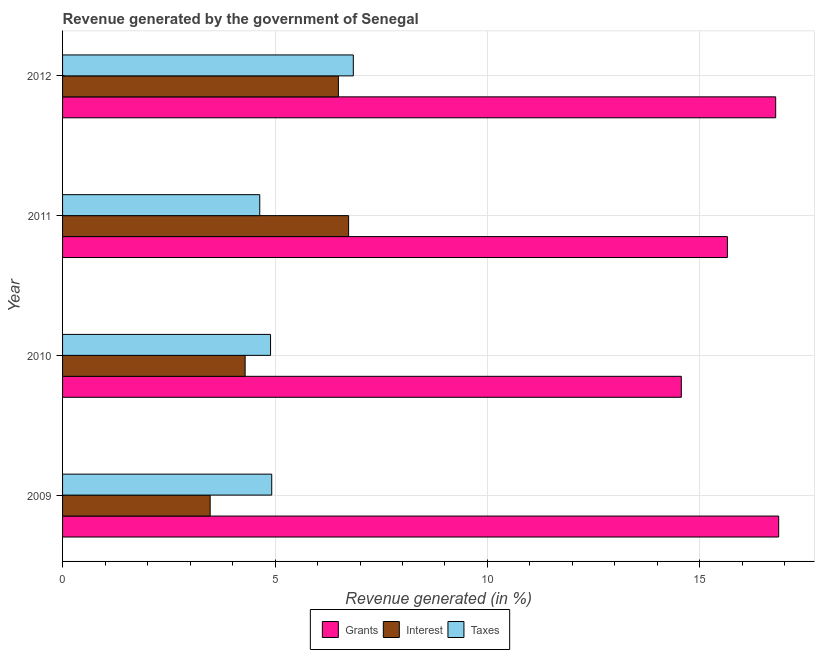How many groups of bars are there?
Provide a succinct answer. 4. Are the number of bars on each tick of the Y-axis equal?
Give a very brief answer. Yes. What is the label of the 2nd group of bars from the top?
Your answer should be compact. 2011. In how many cases, is the number of bars for a given year not equal to the number of legend labels?
Ensure brevity in your answer.  0. What is the percentage of revenue generated by grants in 2011?
Make the answer very short. 15.65. Across all years, what is the maximum percentage of revenue generated by taxes?
Your response must be concise. 6.84. Across all years, what is the minimum percentage of revenue generated by interest?
Your answer should be compact. 3.47. What is the total percentage of revenue generated by grants in the graph?
Your answer should be compact. 63.84. What is the difference between the percentage of revenue generated by interest in 2011 and that in 2012?
Keep it short and to the point. 0.24. What is the difference between the percentage of revenue generated by grants in 2010 and the percentage of revenue generated by taxes in 2011?
Offer a very short reply. 9.92. What is the average percentage of revenue generated by taxes per year?
Keep it short and to the point. 5.33. In the year 2009, what is the difference between the percentage of revenue generated by taxes and percentage of revenue generated by grants?
Your answer should be very brief. -11.93. What is the ratio of the percentage of revenue generated by taxes in 2011 to that in 2012?
Provide a short and direct response. 0.68. Is the percentage of revenue generated by interest in 2009 less than that in 2010?
Make the answer very short. Yes. What is the difference between the highest and the second highest percentage of revenue generated by grants?
Your answer should be compact. 0.07. What is the difference between the highest and the lowest percentage of revenue generated by grants?
Keep it short and to the point. 2.29. Is the sum of the percentage of revenue generated by interest in 2010 and 2011 greater than the maximum percentage of revenue generated by taxes across all years?
Offer a terse response. Yes. What does the 3rd bar from the top in 2010 represents?
Provide a succinct answer. Grants. What does the 2nd bar from the bottom in 2012 represents?
Ensure brevity in your answer.  Interest. Is it the case that in every year, the sum of the percentage of revenue generated by grants and percentage of revenue generated by interest is greater than the percentage of revenue generated by taxes?
Ensure brevity in your answer.  Yes. Does the graph contain any zero values?
Offer a very short reply. No. Where does the legend appear in the graph?
Provide a succinct answer. Bottom center. How many legend labels are there?
Offer a terse response. 3. How are the legend labels stacked?
Keep it short and to the point. Horizontal. What is the title of the graph?
Keep it short and to the point. Revenue generated by the government of Senegal. Does "Profit Tax" appear as one of the legend labels in the graph?
Your answer should be compact. No. What is the label or title of the X-axis?
Make the answer very short. Revenue generated (in %). What is the Revenue generated (in %) in Grants in 2009?
Give a very brief answer. 16.85. What is the Revenue generated (in %) in Interest in 2009?
Give a very brief answer. 3.47. What is the Revenue generated (in %) in Taxes in 2009?
Your answer should be compact. 4.92. What is the Revenue generated (in %) of Grants in 2010?
Make the answer very short. 14.56. What is the Revenue generated (in %) in Interest in 2010?
Your answer should be very brief. 4.3. What is the Revenue generated (in %) of Taxes in 2010?
Make the answer very short. 4.89. What is the Revenue generated (in %) in Grants in 2011?
Your answer should be very brief. 15.65. What is the Revenue generated (in %) in Interest in 2011?
Make the answer very short. 6.73. What is the Revenue generated (in %) of Taxes in 2011?
Give a very brief answer. 4.64. What is the Revenue generated (in %) in Grants in 2012?
Make the answer very short. 16.78. What is the Revenue generated (in %) in Interest in 2012?
Make the answer very short. 6.49. What is the Revenue generated (in %) in Taxes in 2012?
Give a very brief answer. 6.84. Across all years, what is the maximum Revenue generated (in %) of Grants?
Offer a very short reply. 16.85. Across all years, what is the maximum Revenue generated (in %) of Interest?
Provide a short and direct response. 6.73. Across all years, what is the maximum Revenue generated (in %) in Taxes?
Provide a short and direct response. 6.84. Across all years, what is the minimum Revenue generated (in %) in Grants?
Ensure brevity in your answer.  14.56. Across all years, what is the minimum Revenue generated (in %) of Interest?
Your answer should be very brief. 3.47. Across all years, what is the minimum Revenue generated (in %) of Taxes?
Ensure brevity in your answer.  4.64. What is the total Revenue generated (in %) in Grants in the graph?
Offer a terse response. 63.84. What is the total Revenue generated (in %) of Interest in the graph?
Offer a very short reply. 20.99. What is the total Revenue generated (in %) of Taxes in the graph?
Your answer should be very brief. 21.3. What is the difference between the Revenue generated (in %) of Grants in 2009 and that in 2010?
Your response must be concise. 2.29. What is the difference between the Revenue generated (in %) of Interest in 2009 and that in 2010?
Give a very brief answer. -0.82. What is the difference between the Revenue generated (in %) in Taxes in 2009 and that in 2010?
Provide a succinct answer. 0.03. What is the difference between the Revenue generated (in %) in Grants in 2009 and that in 2011?
Provide a succinct answer. 1.21. What is the difference between the Revenue generated (in %) of Interest in 2009 and that in 2011?
Your answer should be compact. -3.26. What is the difference between the Revenue generated (in %) of Taxes in 2009 and that in 2011?
Offer a very short reply. 0.28. What is the difference between the Revenue generated (in %) of Grants in 2009 and that in 2012?
Your response must be concise. 0.07. What is the difference between the Revenue generated (in %) of Interest in 2009 and that in 2012?
Your response must be concise. -3.02. What is the difference between the Revenue generated (in %) in Taxes in 2009 and that in 2012?
Keep it short and to the point. -1.92. What is the difference between the Revenue generated (in %) in Grants in 2010 and that in 2011?
Provide a short and direct response. -1.08. What is the difference between the Revenue generated (in %) in Interest in 2010 and that in 2011?
Make the answer very short. -2.44. What is the difference between the Revenue generated (in %) of Taxes in 2010 and that in 2011?
Offer a very short reply. 0.25. What is the difference between the Revenue generated (in %) in Grants in 2010 and that in 2012?
Offer a terse response. -2.22. What is the difference between the Revenue generated (in %) of Interest in 2010 and that in 2012?
Your response must be concise. -2.2. What is the difference between the Revenue generated (in %) of Taxes in 2010 and that in 2012?
Your response must be concise. -1.95. What is the difference between the Revenue generated (in %) of Grants in 2011 and that in 2012?
Ensure brevity in your answer.  -1.14. What is the difference between the Revenue generated (in %) of Interest in 2011 and that in 2012?
Give a very brief answer. 0.24. What is the difference between the Revenue generated (in %) of Taxes in 2011 and that in 2012?
Ensure brevity in your answer.  -2.2. What is the difference between the Revenue generated (in %) of Grants in 2009 and the Revenue generated (in %) of Interest in 2010?
Ensure brevity in your answer.  12.56. What is the difference between the Revenue generated (in %) of Grants in 2009 and the Revenue generated (in %) of Taxes in 2010?
Provide a short and direct response. 11.96. What is the difference between the Revenue generated (in %) of Interest in 2009 and the Revenue generated (in %) of Taxes in 2010?
Your answer should be compact. -1.42. What is the difference between the Revenue generated (in %) of Grants in 2009 and the Revenue generated (in %) of Interest in 2011?
Provide a succinct answer. 10.12. What is the difference between the Revenue generated (in %) in Grants in 2009 and the Revenue generated (in %) in Taxes in 2011?
Provide a succinct answer. 12.21. What is the difference between the Revenue generated (in %) of Interest in 2009 and the Revenue generated (in %) of Taxes in 2011?
Ensure brevity in your answer.  -1.17. What is the difference between the Revenue generated (in %) of Grants in 2009 and the Revenue generated (in %) of Interest in 2012?
Provide a succinct answer. 10.36. What is the difference between the Revenue generated (in %) in Grants in 2009 and the Revenue generated (in %) in Taxes in 2012?
Give a very brief answer. 10.01. What is the difference between the Revenue generated (in %) in Interest in 2009 and the Revenue generated (in %) in Taxes in 2012?
Provide a short and direct response. -3.37. What is the difference between the Revenue generated (in %) of Grants in 2010 and the Revenue generated (in %) of Interest in 2011?
Your response must be concise. 7.83. What is the difference between the Revenue generated (in %) in Grants in 2010 and the Revenue generated (in %) in Taxes in 2011?
Make the answer very short. 9.92. What is the difference between the Revenue generated (in %) of Interest in 2010 and the Revenue generated (in %) of Taxes in 2011?
Offer a terse response. -0.34. What is the difference between the Revenue generated (in %) of Grants in 2010 and the Revenue generated (in %) of Interest in 2012?
Your answer should be very brief. 8.07. What is the difference between the Revenue generated (in %) in Grants in 2010 and the Revenue generated (in %) in Taxes in 2012?
Your answer should be very brief. 7.72. What is the difference between the Revenue generated (in %) of Interest in 2010 and the Revenue generated (in %) of Taxes in 2012?
Give a very brief answer. -2.55. What is the difference between the Revenue generated (in %) in Grants in 2011 and the Revenue generated (in %) in Interest in 2012?
Offer a terse response. 9.15. What is the difference between the Revenue generated (in %) in Grants in 2011 and the Revenue generated (in %) in Taxes in 2012?
Provide a succinct answer. 8.8. What is the difference between the Revenue generated (in %) of Interest in 2011 and the Revenue generated (in %) of Taxes in 2012?
Offer a very short reply. -0.11. What is the average Revenue generated (in %) of Grants per year?
Make the answer very short. 15.96. What is the average Revenue generated (in %) of Interest per year?
Make the answer very short. 5.25. What is the average Revenue generated (in %) in Taxes per year?
Your response must be concise. 5.33. In the year 2009, what is the difference between the Revenue generated (in %) of Grants and Revenue generated (in %) of Interest?
Provide a succinct answer. 13.38. In the year 2009, what is the difference between the Revenue generated (in %) in Grants and Revenue generated (in %) in Taxes?
Make the answer very short. 11.93. In the year 2009, what is the difference between the Revenue generated (in %) of Interest and Revenue generated (in %) of Taxes?
Your response must be concise. -1.45. In the year 2010, what is the difference between the Revenue generated (in %) in Grants and Revenue generated (in %) in Interest?
Provide a succinct answer. 10.27. In the year 2010, what is the difference between the Revenue generated (in %) of Grants and Revenue generated (in %) of Taxes?
Make the answer very short. 9.67. In the year 2010, what is the difference between the Revenue generated (in %) in Interest and Revenue generated (in %) in Taxes?
Keep it short and to the point. -0.6. In the year 2011, what is the difference between the Revenue generated (in %) in Grants and Revenue generated (in %) in Interest?
Your answer should be compact. 8.91. In the year 2011, what is the difference between the Revenue generated (in %) in Grants and Revenue generated (in %) in Taxes?
Your answer should be very brief. 11.01. In the year 2011, what is the difference between the Revenue generated (in %) of Interest and Revenue generated (in %) of Taxes?
Your answer should be very brief. 2.09. In the year 2012, what is the difference between the Revenue generated (in %) of Grants and Revenue generated (in %) of Interest?
Offer a terse response. 10.29. In the year 2012, what is the difference between the Revenue generated (in %) in Grants and Revenue generated (in %) in Taxes?
Keep it short and to the point. 9.94. In the year 2012, what is the difference between the Revenue generated (in %) of Interest and Revenue generated (in %) of Taxes?
Keep it short and to the point. -0.35. What is the ratio of the Revenue generated (in %) of Grants in 2009 to that in 2010?
Ensure brevity in your answer.  1.16. What is the ratio of the Revenue generated (in %) in Interest in 2009 to that in 2010?
Offer a terse response. 0.81. What is the ratio of the Revenue generated (in %) of Grants in 2009 to that in 2011?
Give a very brief answer. 1.08. What is the ratio of the Revenue generated (in %) of Interest in 2009 to that in 2011?
Your answer should be compact. 0.52. What is the ratio of the Revenue generated (in %) in Taxes in 2009 to that in 2011?
Make the answer very short. 1.06. What is the ratio of the Revenue generated (in %) of Grants in 2009 to that in 2012?
Give a very brief answer. 1. What is the ratio of the Revenue generated (in %) of Interest in 2009 to that in 2012?
Your answer should be very brief. 0.54. What is the ratio of the Revenue generated (in %) in Taxes in 2009 to that in 2012?
Offer a terse response. 0.72. What is the ratio of the Revenue generated (in %) in Grants in 2010 to that in 2011?
Provide a short and direct response. 0.93. What is the ratio of the Revenue generated (in %) of Interest in 2010 to that in 2011?
Your answer should be compact. 0.64. What is the ratio of the Revenue generated (in %) in Taxes in 2010 to that in 2011?
Make the answer very short. 1.05. What is the ratio of the Revenue generated (in %) of Grants in 2010 to that in 2012?
Keep it short and to the point. 0.87. What is the ratio of the Revenue generated (in %) of Interest in 2010 to that in 2012?
Give a very brief answer. 0.66. What is the ratio of the Revenue generated (in %) in Taxes in 2010 to that in 2012?
Offer a very short reply. 0.72. What is the ratio of the Revenue generated (in %) of Grants in 2011 to that in 2012?
Offer a terse response. 0.93. What is the ratio of the Revenue generated (in %) of Interest in 2011 to that in 2012?
Give a very brief answer. 1.04. What is the ratio of the Revenue generated (in %) in Taxes in 2011 to that in 2012?
Ensure brevity in your answer.  0.68. What is the difference between the highest and the second highest Revenue generated (in %) in Grants?
Provide a short and direct response. 0.07. What is the difference between the highest and the second highest Revenue generated (in %) in Interest?
Keep it short and to the point. 0.24. What is the difference between the highest and the second highest Revenue generated (in %) of Taxes?
Your response must be concise. 1.92. What is the difference between the highest and the lowest Revenue generated (in %) in Grants?
Offer a terse response. 2.29. What is the difference between the highest and the lowest Revenue generated (in %) of Interest?
Keep it short and to the point. 3.26. What is the difference between the highest and the lowest Revenue generated (in %) of Taxes?
Ensure brevity in your answer.  2.2. 